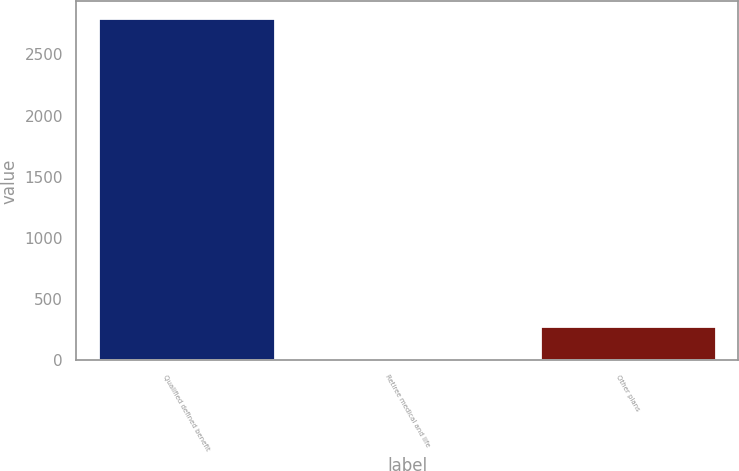Convert chart. <chart><loc_0><loc_0><loc_500><loc_500><bar_chart><fcel>Qualified defined benefit<fcel>Retiree medical and life<fcel>Other plans<nl><fcel>2793<fcel>1<fcel>280.2<nl></chart> 